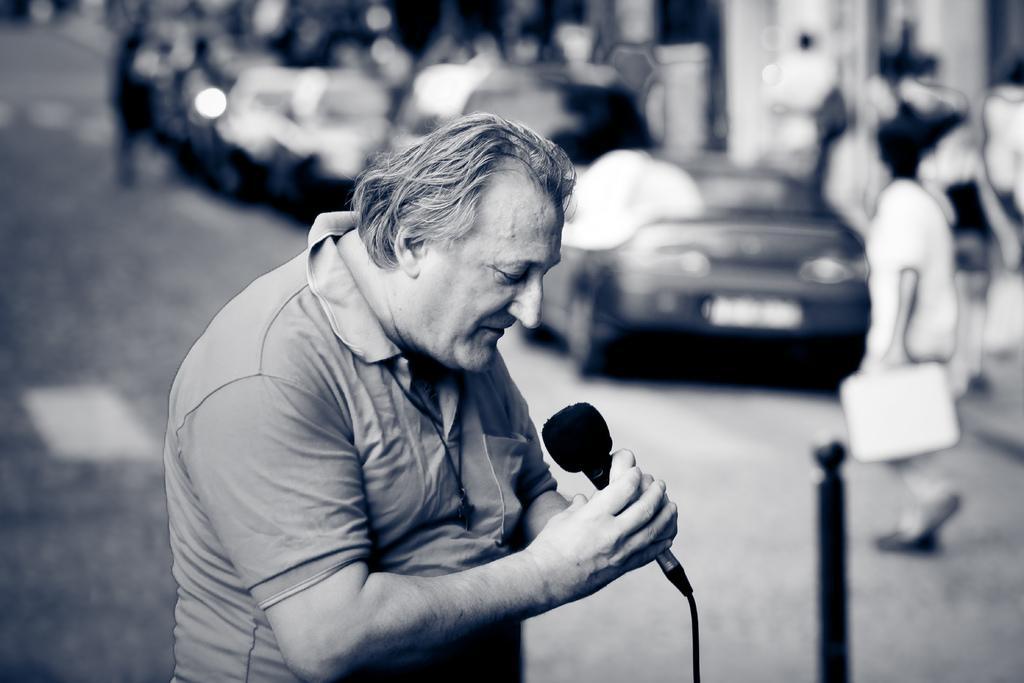Please provide a concise description of this image. In this image there is a man wearing T-shirt holding a microphone in his hand and at the background of the image there are cars and persons walking on the road. 